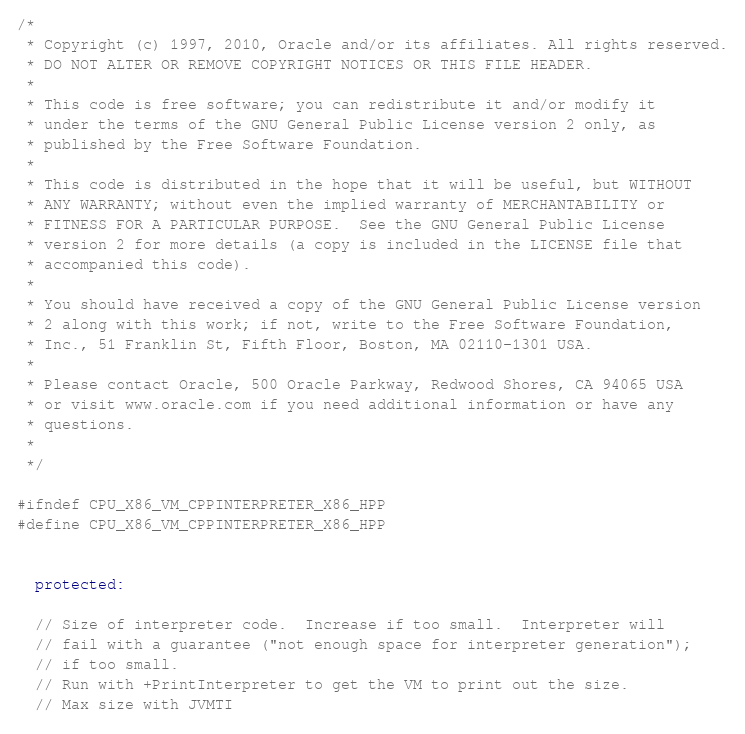Convert code to text. <code><loc_0><loc_0><loc_500><loc_500><_C++_>/*
 * Copyright (c) 1997, 2010, Oracle and/or its affiliates. All rights reserved.
 * DO NOT ALTER OR REMOVE COPYRIGHT NOTICES OR THIS FILE HEADER.
 *
 * This code is free software; you can redistribute it and/or modify it
 * under the terms of the GNU General Public License version 2 only, as
 * published by the Free Software Foundation.
 *
 * This code is distributed in the hope that it will be useful, but WITHOUT
 * ANY WARRANTY; without even the implied warranty of MERCHANTABILITY or
 * FITNESS FOR A PARTICULAR PURPOSE.  See the GNU General Public License
 * version 2 for more details (a copy is included in the LICENSE file that
 * accompanied this code).
 *
 * You should have received a copy of the GNU General Public License version
 * 2 along with this work; if not, write to the Free Software Foundation,
 * Inc., 51 Franklin St, Fifth Floor, Boston, MA 02110-1301 USA.
 *
 * Please contact Oracle, 500 Oracle Parkway, Redwood Shores, CA 94065 USA
 * or visit www.oracle.com if you need additional information or have any
 * questions.
 *
 */

#ifndef CPU_X86_VM_CPPINTERPRETER_X86_HPP
#define CPU_X86_VM_CPPINTERPRETER_X86_HPP


  protected:

  // Size of interpreter code.  Increase if too small.  Interpreter will
  // fail with a guarantee ("not enough space for interpreter generation");
  // if too small.
  // Run with +PrintInterpreter to get the VM to print out the size.
  // Max size with JVMTI</code> 